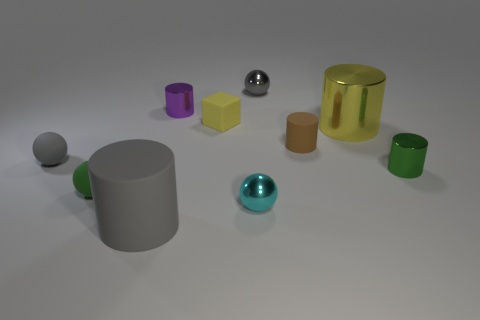Subtract all brown cylinders. How many cylinders are left? 4 Subtract all small rubber cylinders. How many cylinders are left? 4 Subtract all purple balls. Subtract all blue cylinders. How many balls are left? 4 Subtract all spheres. How many objects are left? 6 Subtract 0 cyan cylinders. How many objects are left? 10 Subtract all small yellow shiny cylinders. Subtract all tiny objects. How many objects are left? 2 Add 4 small gray balls. How many small gray balls are left? 6 Add 9 tiny gray rubber cylinders. How many tiny gray rubber cylinders exist? 9 